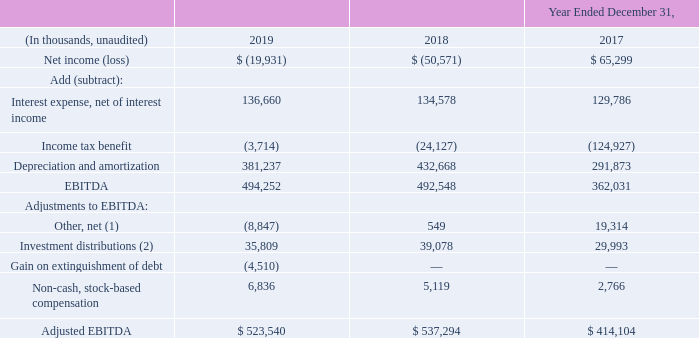Non-GAAP Measures
In addition to the results reported in accordance with US GAAP, we also use certain non-GAAP measures such as EBITDA and adjusted EBITDA to evaluate operating performance and to facilitate the comparison of our historical results and trends. These financial measures are not a measure of financial performance under US GAAP and should not be considered in isolation or as a substitute for net income as a measure of performance and net cash provided by operating activities as a measure of liquidity.
They are not, on their own, necessarily indicative of cash available to fund cash needs as determined in accordance with GAAP. The calculation of these non-GAAP measures may not be comparable to similarly titled measures used by other companies. Reconciliations of these non-GAAP measures to the most directly comparable financial measures presented in accordance with GAAP are provided below.
EBITDA is defined as net earnings before interest expense, income taxes, and depreciation and amortization. Adjusted EBITDA is comprised of EBITDA, adjusted for certain items as permitted or required under our credit facility as described in the reconciliations below. These measures are a common measure of operating performance in the telecommunications industry and are useful, with other data, as a means to evaluate our ability to fund our estimated uses of cash.
The following tables are a reconciliation of net income (loss) to adjusted EBITDA for the years ended December 31, 2019, 2018 and 2017:
(1) Other, net includes the equity earnings from our investments, dividend income, income attributable to noncontrolling interests in subsidiaries, acquisition and transaction related costs including integration and severance, non-cash pension and post-retirement benefits and certain other miscellaneous items. (2) Includes all cash dividends and other cash distributions received from our investments.
Which non-GAAP measures are used? Ebitda and adjusted ebitda. What is the purpose of using EBITDA and adjusted EBITDA? To evaluate operating performance and to facilitate the comparison of our historical results and trends. Which Industry commonly uses EBITDA and adjusted EBITDA for measuring operating performance? Telecommunications industry. What is the increase/ (decrease) in Net income (loss) from 2018 to 2019?
Answer scale should be: thousand. -19,931-(-50,571)
Answer: 30640. What is the increase/ (decrease) in Interest expense, net of interest income from 2018 to 2019?
Answer scale should be: thousand. 136,660-134,578
Answer: 2082. What is the increase/ (decrease) in Income tax expense (benefit) from 2018 to 2019?
Answer scale should be: thousand. -3,714-(-24,127)
Answer: 20413. 